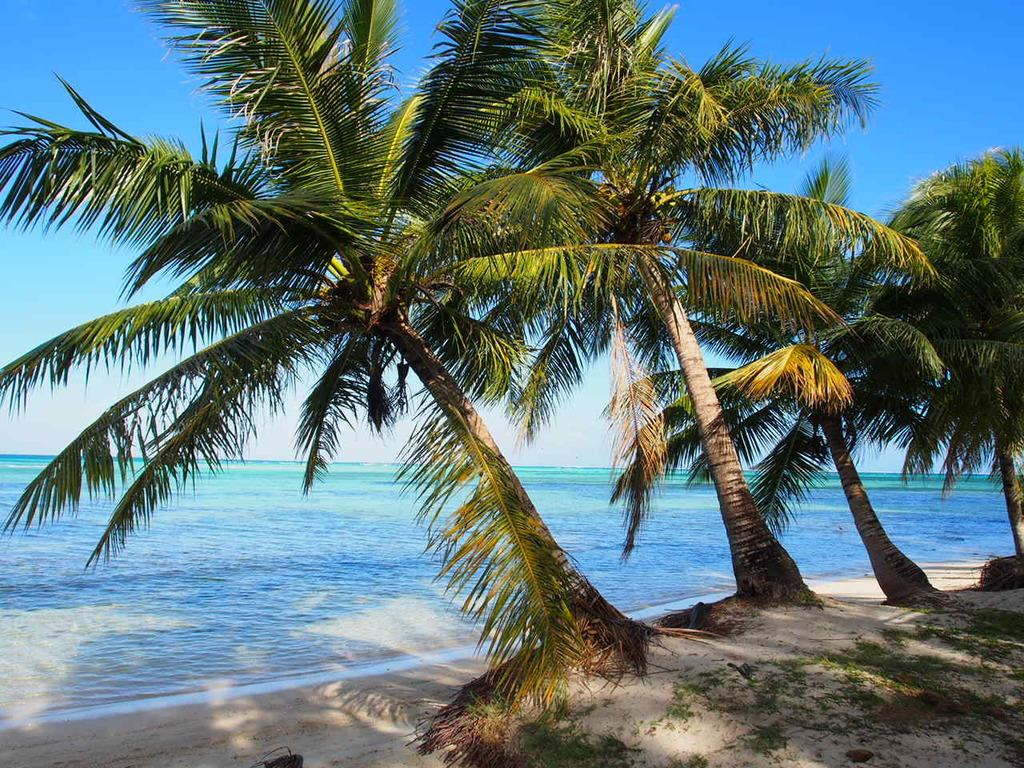What type of vegetation can be seen in the image? There are trees in the image. Where are the trees located? The trees are located on a beach. What can be seen in the background of the image? There is an ocean and the sky visible in the background of the image. How many pairs of jeans are hanging on the trees in the image? There are no jeans present in the image; it features trees on a beach with an ocean and sky in the background. 